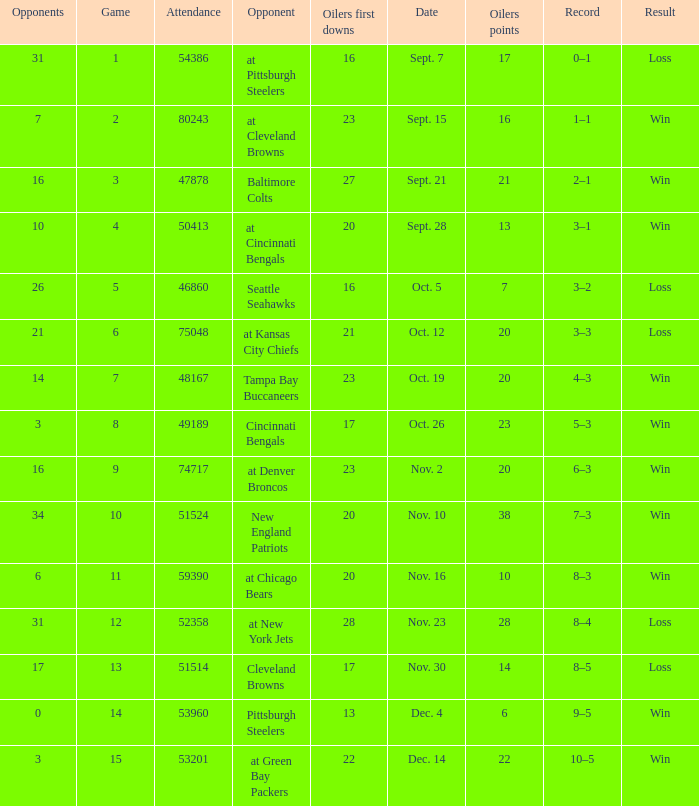What was the total opponents points for the game were the Oilers scored 21? 16.0. 